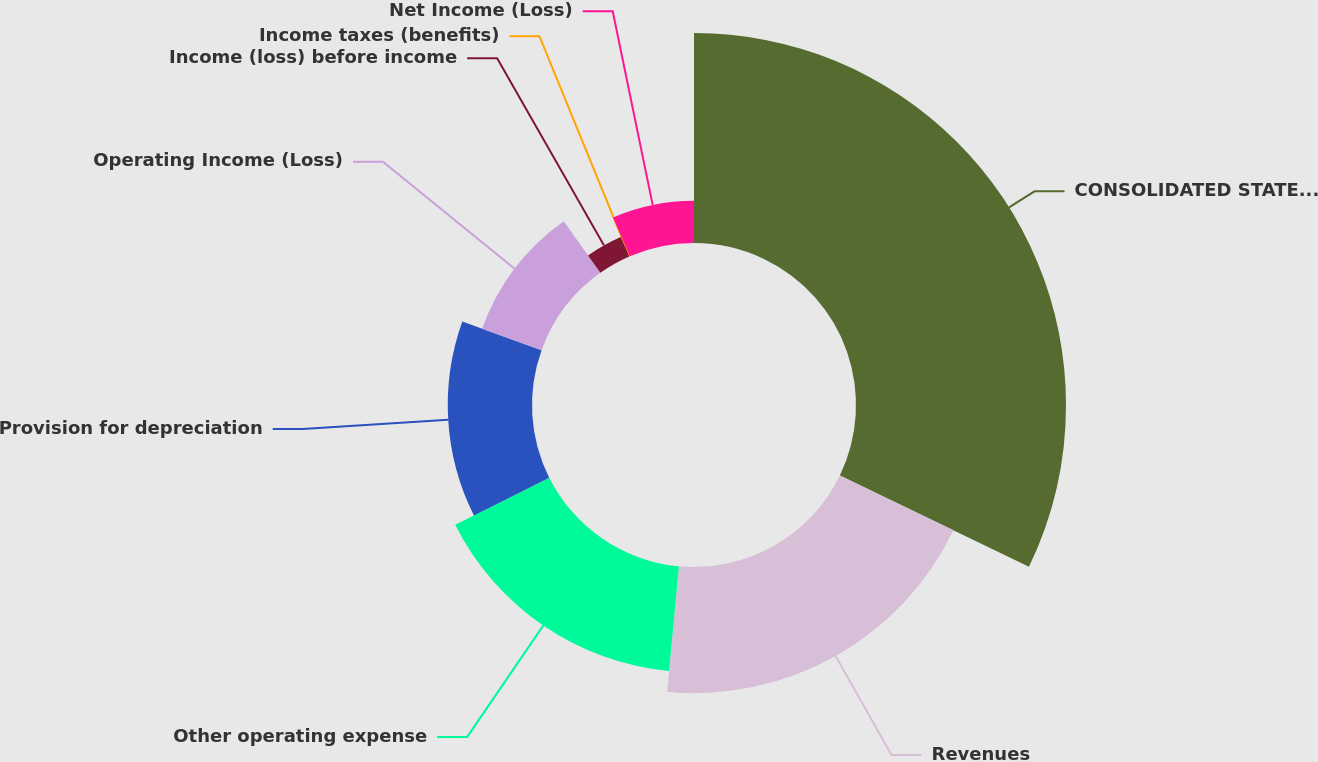<chart> <loc_0><loc_0><loc_500><loc_500><pie_chart><fcel>CONSOLIDATED STATEMENTS OF<fcel>Revenues<fcel>Other operating expense<fcel>Provision for depreciation<fcel>Operating Income (Loss)<fcel>Income (loss) before income<fcel>Income taxes (benefits)<fcel>Net Income (Loss)<nl><fcel>32.16%<fcel>19.32%<fcel>16.11%<fcel>12.9%<fcel>9.69%<fcel>3.27%<fcel>0.06%<fcel>6.48%<nl></chart> 